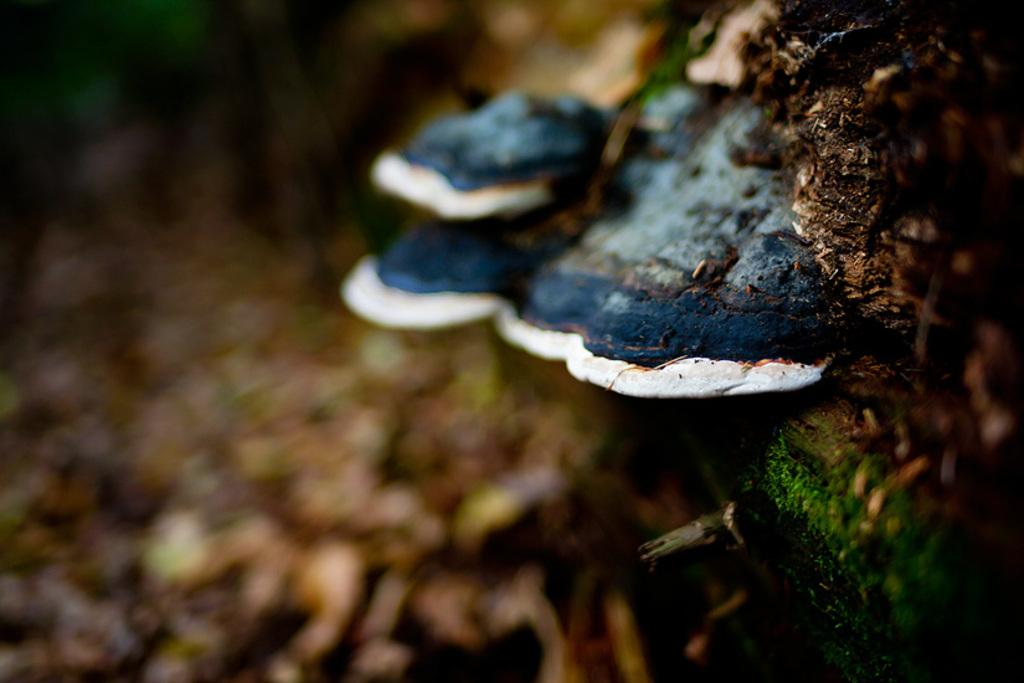What is the main subject of the image? The main subject of the image is mushrooms. Can you describe the appearance of the mushrooms? The mushrooms are in white and blue color. Are there any other objects in the image besides the mushrooms? Yes, there are a few other objects in the image. How would you describe the background of the image? The background of the image is blurred. How many kittens are playing with the mushrooms in the image? There are no kittens present in the image; it features mushrooms and other objects. What type of industry is depicted in the background of the image? There is no industry depicted in the image; the background is blurred. 